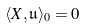<formula> <loc_0><loc_0><loc_500><loc_500>\langle X , \mathfrak { u } \rangle _ { 0 } = 0</formula> 